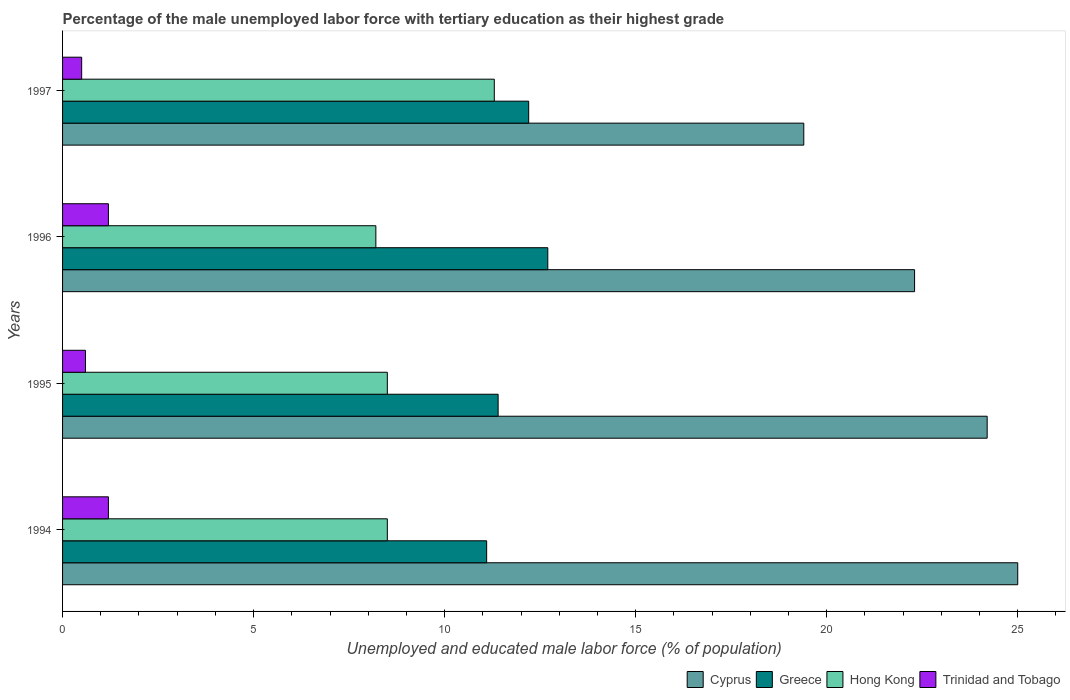How many different coloured bars are there?
Your answer should be very brief. 4. How many bars are there on the 3rd tick from the top?
Give a very brief answer. 4. What is the label of the 4th group of bars from the top?
Your answer should be compact. 1994. In how many cases, is the number of bars for a given year not equal to the number of legend labels?
Your answer should be very brief. 0. What is the percentage of the unemployed male labor force with tertiary education in Trinidad and Tobago in 1994?
Ensure brevity in your answer.  1.2. Across all years, what is the maximum percentage of the unemployed male labor force with tertiary education in Greece?
Your response must be concise. 12.7. Across all years, what is the minimum percentage of the unemployed male labor force with tertiary education in Cyprus?
Your answer should be compact. 19.4. In which year was the percentage of the unemployed male labor force with tertiary education in Cyprus maximum?
Offer a terse response. 1994. In which year was the percentage of the unemployed male labor force with tertiary education in Trinidad and Tobago minimum?
Your answer should be compact. 1997. What is the total percentage of the unemployed male labor force with tertiary education in Hong Kong in the graph?
Offer a terse response. 36.5. What is the difference between the percentage of the unemployed male labor force with tertiary education in Hong Kong in 1996 and that in 1997?
Give a very brief answer. -3.1. What is the difference between the percentage of the unemployed male labor force with tertiary education in Cyprus in 1994 and the percentage of the unemployed male labor force with tertiary education in Hong Kong in 1997?
Your answer should be compact. 13.7. What is the average percentage of the unemployed male labor force with tertiary education in Hong Kong per year?
Offer a terse response. 9.13. In the year 1994, what is the difference between the percentage of the unemployed male labor force with tertiary education in Greece and percentage of the unemployed male labor force with tertiary education in Cyprus?
Provide a short and direct response. -13.9. In how many years, is the percentage of the unemployed male labor force with tertiary education in Cyprus greater than 8 %?
Your answer should be compact. 4. What is the ratio of the percentage of the unemployed male labor force with tertiary education in Trinidad and Tobago in 1995 to that in 1996?
Provide a succinct answer. 0.5. What is the difference between the highest and the lowest percentage of the unemployed male labor force with tertiary education in Greece?
Offer a very short reply. 1.6. Is the sum of the percentage of the unemployed male labor force with tertiary education in Cyprus in 1996 and 1997 greater than the maximum percentage of the unemployed male labor force with tertiary education in Hong Kong across all years?
Offer a very short reply. Yes. Is it the case that in every year, the sum of the percentage of the unemployed male labor force with tertiary education in Trinidad and Tobago and percentage of the unemployed male labor force with tertiary education in Hong Kong is greater than the sum of percentage of the unemployed male labor force with tertiary education in Cyprus and percentage of the unemployed male labor force with tertiary education in Greece?
Your answer should be very brief. No. What does the 4th bar from the top in 1997 represents?
Offer a terse response. Cyprus. What does the 1st bar from the bottom in 1995 represents?
Offer a terse response. Cyprus. Is it the case that in every year, the sum of the percentage of the unemployed male labor force with tertiary education in Greece and percentage of the unemployed male labor force with tertiary education in Trinidad and Tobago is greater than the percentage of the unemployed male labor force with tertiary education in Hong Kong?
Ensure brevity in your answer.  Yes. Are all the bars in the graph horizontal?
Offer a very short reply. Yes. How many years are there in the graph?
Keep it short and to the point. 4. What is the difference between two consecutive major ticks on the X-axis?
Make the answer very short. 5. Does the graph contain any zero values?
Your response must be concise. No. How many legend labels are there?
Ensure brevity in your answer.  4. How are the legend labels stacked?
Offer a terse response. Horizontal. What is the title of the graph?
Your response must be concise. Percentage of the male unemployed labor force with tertiary education as their highest grade. Does "Moldova" appear as one of the legend labels in the graph?
Give a very brief answer. No. What is the label or title of the X-axis?
Offer a very short reply. Unemployed and educated male labor force (% of population). What is the Unemployed and educated male labor force (% of population) in Cyprus in 1994?
Ensure brevity in your answer.  25. What is the Unemployed and educated male labor force (% of population) of Greece in 1994?
Keep it short and to the point. 11.1. What is the Unemployed and educated male labor force (% of population) in Trinidad and Tobago in 1994?
Your answer should be very brief. 1.2. What is the Unemployed and educated male labor force (% of population) in Cyprus in 1995?
Provide a succinct answer. 24.2. What is the Unemployed and educated male labor force (% of population) in Greece in 1995?
Provide a short and direct response. 11.4. What is the Unemployed and educated male labor force (% of population) in Hong Kong in 1995?
Your response must be concise. 8.5. What is the Unemployed and educated male labor force (% of population) in Trinidad and Tobago in 1995?
Your answer should be compact. 0.6. What is the Unemployed and educated male labor force (% of population) of Cyprus in 1996?
Your response must be concise. 22.3. What is the Unemployed and educated male labor force (% of population) in Greece in 1996?
Offer a very short reply. 12.7. What is the Unemployed and educated male labor force (% of population) of Hong Kong in 1996?
Your answer should be compact. 8.2. What is the Unemployed and educated male labor force (% of population) in Trinidad and Tobago in 1996?
Provide a succinct answer. 1.2. What is the Unemployed and educated male labor force (% of population) in Cyprus in 1997?
Ensure brevity in your answer.  19.4. What is the Unemployed and educated male labor force (% of population) in Greece in 1997?
Give a very brief answer. 12.2. What is the Unemployed and educated male labor force (% of population) in Hong Kong in 1997?
Give a very brief answer. 11.3. What is the Unemployed and educated male labor force (% of population) of Trinidad and Tobago in 1997?
Provide a succinct answer. 0.5. Across all years, what is the maximum Unemployed and educated male labor force (% of population) in Greece?
Keep it short and to the point. 12.7. Across all years, what is the maximum Unemployed and educated male labor force (% of population) in Hong Kong?
Offer a very short reply. 11.3. Across all years, what is the maximum Unemployed and educated male labor force (% of population) of Trinidad and Tobago?
Give a very brief answer. 1.2. Across all years, what is the minimum Unemployed and educated male labor force (% of population) in Cyprus?
Offer a terse response. 19.4. Across all years, what is the minimum Unemployed and educated male labor force (% of population) of Greece?
Give a very brief answer. 11.1. Across all years, what is the minimum Unemployed and educated male labor force (% of population) of Hong Kong?
Your answer should be very brief. 8.2. Across all years, what is the minimum Unemployed and educated male labor force (% of population) in Trinidad and Tobago?
Provide a short and direct response. 0.5. What is the total Unemployed and educated male labor force (% of population) of Cyprus in the graph?
Offer a very short reply. 90.9. What is the total Unemployed and educated male labor force (% of population) in Greece in the graph?
Offer a terse response. 47.4. What is the total Unemployed and educated male labor force (% of population) in Hong Kong in the graph?
Your answer should be very brief. 36.5. What is the difference between the Unemployed and educated male labor force (% of population) in Cyprus in 1994 and that in 1995?
Your answer should be very brief. 0.8. What is the difference between the Unemployed and educated male labor force (% of population) in Hong Kong in 1994 and that in 1995?
Ensure brevity in your answer.  0. What is the difference between the Unemployed and educated male labor force (% of population) in Trinidad and Tobago in 1994 and that in 1995?
Provide a succinct answer. 0.6. What is the difference between the Unemployed and educated male labor force (% of population) of Cyprus in 1994 and that in 1996?
Provide a short and direct response. 2.7. What is the difference between the Unemployed and educated male labor force (% of population) of Cyprus in 1994 and that in 1997?
Your response must be concise. 5.6. What is the difference between the Unemployed and educated male labor force (% of population) of Greece in 1994 and that in 1997?
Provide a succinct answer. -1.1. What is the difference between the Unemployed and educated male labor force (% of population) in Greece in 1995 and that in 1996?
Offer a very short reply. -1.3. What is the difference between the Unemployed and educated male labor force (% of population) in Cyprus in 1995 and that in 1997?
Your answer should be compact. 4.8. What is the difference between the Unemployed and educated male labor force (% of population) in Greece in 1995 and that in 1997?
Offer a very short reply. -0.8. What is the difference between the Unemployed and educated male labor force (% of population) of Hong Kong in 1995 and that in 1997?
Offer a terse response. -2.8. What is the difference between the Unemployed and educated male labor force (% of population) in Trinidad and Tobago in 1995 and that in 1997?
Offer a terse response. 0.1. What is the difference between the Unemployed and educated male labor force (% of population) of Greece in 1996 and that in 1997?
Your response must be concise. 0.5. What is the difference between the Unemployed and educated male labor force (% of population) of Hong Kong in 1996 and that in 1997?
Provide a short and direct response. -3.1. What is the difference between the Unemployed and educated male labor force (% of population) in Cyprus in 1994 and the Unemployed and educated male labor force (% of population) in Hong Kong in 1995?
Your answer should be very brief. 16.5. What is the difference between the Unemployed and educated male labor force (% of population) of Cyprus in 1994 and the Unemployed and educated male labor force (% of population) of Trinidad and Tobago in 1995?
Your response must be concise. 24.4. What is the difference between the Unemployed and educated male labor force (% of population) of Greece in 1994 and the Unemployed and educated male labor force (% of population) of Trinidad and Tobago in 1995?
Keep it short and to the point. 10.5. What is the difference between the Unemployed and educated male labor force (% of population) in Hong Kong in 1994 and the Unemployed and educated male labor force (% of population) in Trinidad and Tobago in 1995?
Your response must be concise. 7.9. What is the difference between the Unemployed and educated male labor force (% of population) of Cyprus in 1994 and the Unemployed and educated male labor force (% of population) of Trinidad and Tobago in 1996?
Provide a succinct answer. 23.8. What is the difference between the Unemployed and educated male labor force (% of population) in Greece in 1994 and the Unemployed and educated male labor force (% of population) in Hong Kong in 1996?
Your answer should be compact. 2.9. What is the difference between the Unemployed and educated male labor force (% of population) in Greece in 1994 and the Unemployed and educated male labor force (% of population) in Trinidad and Tobago in 1997?
Offer a terse response. 10.6. What is the difference between the Unemployed and educated male labor force (% of population) of Cyprus in 1995 and the Unemployed and educated male labor force (% of population) of Trinidad and Tobago in 1996?
Your response must be concise. 23. What is the difference between the Unemployed and educated male labor force (% of population) in Greece in 1995 and the Unemployed and educated male labor force (% of population) in Trinidad and Tobago in 1996?
Your answer should be very brief. 10.2. What is the difference between the Unemployed and educated male labor force (% of population) in Hong Kong in 1995 and the Unemployed and educated male labor force (% of population) in Trinidad and Tobago in 1996?
Your response must be concise. 7.3. What is the difference between the Unemployed and educated male labor force (% of population) of Cyprus in 1995 and the Unemployed and educated male labor force (% of population) of Trinidad and Tobago in 1997?
Keep it short and to the point. 23.7. What is the difference between the Unemployed and educated male labor force (% of population) in Greece in 1995 and the Unemployed and educated male labor force (% of population) in Hong Kong in 1997?
Your answer should be compact. 0.1. What is the difference between the Unemployed and educated male labor force (% of population) in Greece in 1995 and the Unemployed and educated male labor force (% of population) in Trinidad and Tobago in 1997?
Give a very brief answer. 10.9. What is the difference between the Unemployed and educated male labor force (% of population) in Cyprus in 1996 and the Unemployed and educated male labor force (% of population) in Greece in 1997?
Make the answer very short. 10.1. What is the difference between the Unemployed and educated male labor force (% of population) in Cyprus in 1996 and the Unemployed and educated male labor force (% of population) in Trinidad and Tobago in 1997?
Your answer should be very brief. 21.8. What is the difference between the Unemployed and educated male labor force (% of population) of Greece in 1996 and the Unemployed and educated male labor force (% of population) of Hong Kong in 1997?
Offer a terse response. 1.4. What is the difference between the Unemployed and educated male labor force (% of population) of Greece in 1996 and the Unemployed and educated male labor force (% of population) of Trinidad and Tobago in 1997?
Make the answer very short. 12.2. What is the difference between the Unemployed and educated male labor force (% of population) in Hong Kong in 1996 and the Unemployed and educated male labor force (% of population) in Trinidad and Tobago in 1997?
Your answer should be very brief. 7.7. What is the average Unemployed and educated male labor force (% of population) of Cyprus per year?
Your answer should be compact. 22.73. What is the average Unemployed and educated male labor force (% of population) of Greece per year?
Provide a short and direct response. 11.85. What is the average Unemployed and educated male labor force (% of population) of Hong Kong per year?
Make the answer very short. 9.12. In the year 1994, what is the difference between the Unemployed and educated male labor force (% of population) in Cyprus and Unemployed and educated male labor force (% of population) in Trinidad and Tobago?
Provide a succinct answer. 23.8. In the year 1994, what is the difference between the Unemployed and educated male labor force (% of population) in Greece and Unemployed and educated male labor force (% of population) in Trinidad and Tobago?
Make the answer very short. 9.9. In the year 1994, what is the difference between the Unemployed and educated male labor force (% of population) of Hong Kong and Unemployed and educated male labor force (% of population) of Trinidad and Tobago?
Offer a very short reply. 7.3. In the year 1995, what is the difference between the Unemployed and educated male labor force (% of population) of Cyprus and Unemployed and educated male labor force (% of population) of Greece?
Ensure brevity in your answer.  12.8. In the year 1995, what is the difference between the Unemployed and educated male labor force (% of population) in Cyprus and Unemployed and educated male labor force (% of population) in Trinidad and Tobago?
Offer a terse response. 23.6. In the year 1995, what is the difference between the Unemployed and educated male labor force (% of population) of Greece and Unemployed and educated male labor force (% of population) of Trinidad and Tobago?
Offer a terse response. 10.8. In the year 1996, what is the difference between the Unemployed and educated male labor force (% of population) of Cyprus and Unemployed and educated male labor force (% of population) of Greece?
Your answer should be compact. 9.6. In the year 1996, what is the difference between the Unemployed and educated male labor force (% of population) of Cyprus and Unemployed and educated male labor force (% of population) of Trinidad and Tobago?
Provide a succinct answer. 21.1. In the year 1997, what is the difference between the Unemployed and educated male labor force (% of population) of Cyprus and Unemployed and educated male labor force (% of population) of Greece?
Provide a succinct answer. 7.2. In the year 1997, what is the difference between the Unemployed and educated male labor force (% of population) in Greece and Unemployed and educated male labor force (% of population) in Hong Kong?
Your answer should be compact. 0.9. In the year 1997, what is the difference between the Unemployed and educated male labor force (% of population) in Hong Kong and Unemployed and educated male labor force (% of population) in Trinidad and Tobago?
Give a very brief answer. 10.8. What is the ratio of the Unemployed and educated male labor force (% of population) of Cyprus in 1994 to that in 1995?
Your answer should be compact. 1.03. What is the ratio of the Unemployed and educated male labor force (% of population) in Greece in 1994 to that in 1995?
Your answer should be compact. 0.97. What is the ratio of the Unemployed and educated male labor force (% of population) in Hong Kong in 1994 to that in 1995?
Offer a terse response. 1. What is the ratio of the Unemployed and educated male labor force (% of population) of Trinidad and Tobago in 1994 to that in 1995?
Provide a short and direct response. 2. What is the ratio of the Unemployed and educated male labor force (% of population) in Cyprus in 1994 to that in 1996?
Offer a very short reply. 1.12. What is the ratio of the Unemployed and educated male labor force (% of population) of Greece in 1994 to that in 1996?
Ensure brevity in your answer.  0.87. What is the ratio of the Unemployed and educated male labor force (% of population) in Hong Kong in 1994 to that in 1996?
Give a very brief answer. 1.04. What is the ratio of the Unemployed and educated male labor force (% of population) in Trinidad and Tobago in 1994 to that in 1996?
Offer a terse response. 1. What is the ratio of the Unemployed and educated male labor force (% of population) in Cyprus in 1994 to that in 1997?
Your answer should be compact. 1.29. What is the ratio of the Unemployed and educated male labor force (% of population) of Greece in 1994 to that in 1997?
Keep it short and to the point. 0.91. What is the ratio of the Unemployed and educated male labor force (% of population) in Hong Kong in 1994 to that in 1997?
Offer a very short reply. 0.75. What is the ratio of the Unemployed and educated male labor force (% of population) of Trinidad and Tobago in 1994 to that in 1997?
Offer a very short reply. 2.4. What is the ratio of the Unemployed and educated male labor force (% of population) in Cyprus in 1995 to that in 1996?
Your response must be concise. 1.09. What is the ratio of the Unemployed and educated male labor force (% of population) in Greece in 1995 to that in 1996?
Give a very brief answer. 0.9. What is the ratio of the Unemployed and educated male labor force (% of population) of Hong Kong in 1995 to that in 1996?
Your response must be concise. 1.04. What is the ratio of the Unemployed and educated male labor force (% of population) of Cyprus in 1995 to that in 1997?
Provide a short and direct response. 1.25. What is the ratio of the Unemployed and educated male labor force (% of population) of Greece in 1995 to that in 1997?
Your answer should be very brief. 0.93. What is the ratio of the Unemployed and educated male labor force (% of population) in Hong Kong in 1995 to that in 1997?
Offer a terse response. 0.75. What is the ratio of the Unemployed and educated male labor force (% of population) of Trinidad and Tobago in 1995 to that in 1997?
Ensure brevity in your answer.  1.2. What is the ratio of the Unemployed and educated male labor force (% of population) in Cyprus in 1996 to that in 1997?
Your answer should be compact. 1.15. What is the ratio of the Unemployed and educated male labor force (% of population) of Greece in 1996 to that in 1997?
Provide a succinct answer. 1.04. What is the ratio of the Unemployed and educated male labor force (% of population) of Hong Kong in 1996 to that in 1997?
Provide a succinct answer. 0.73. What is the ratio of the Unemployed and educated male labor force (% of population) of Trinidad and Tobago in 1996 to that in 1997?
Your answer should be very brief. 2.4. What is the difference between the highest and the second highest Unemployed and educated male labor force (% of population) of Greece?
Keep it short and to the point. 0.5. What is the difference between the highest and the second highest Unemployed and educated male labor force (% of population) in Hong Kong?
Keep it short and to the point. 2.8. What is the difference between the highest and the second highest Unemployed and educated male labor force (% of population) of Trinidad and Tobago?
Provide a short and direct response. 0. What is the difference between the highest and the lowest Unemployed and educated male labor force (% of population) in Cyprus?
Your answer should be very brief. 5.6. 